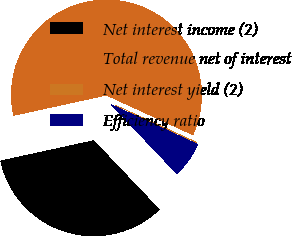Convert chart to OTSL. <chart><loc_0><loc_0><loc_500><loc_500><pie_chart><fcel>Net interest income (2)<fcel>Total revenue net of interest<fcel>Net interest yield (2)<fcel>Efficiency ratio<nl><fcel>33.68%<fcel>60.28%<fcel>0.01%<fcel>6.03%<nl></chart> 